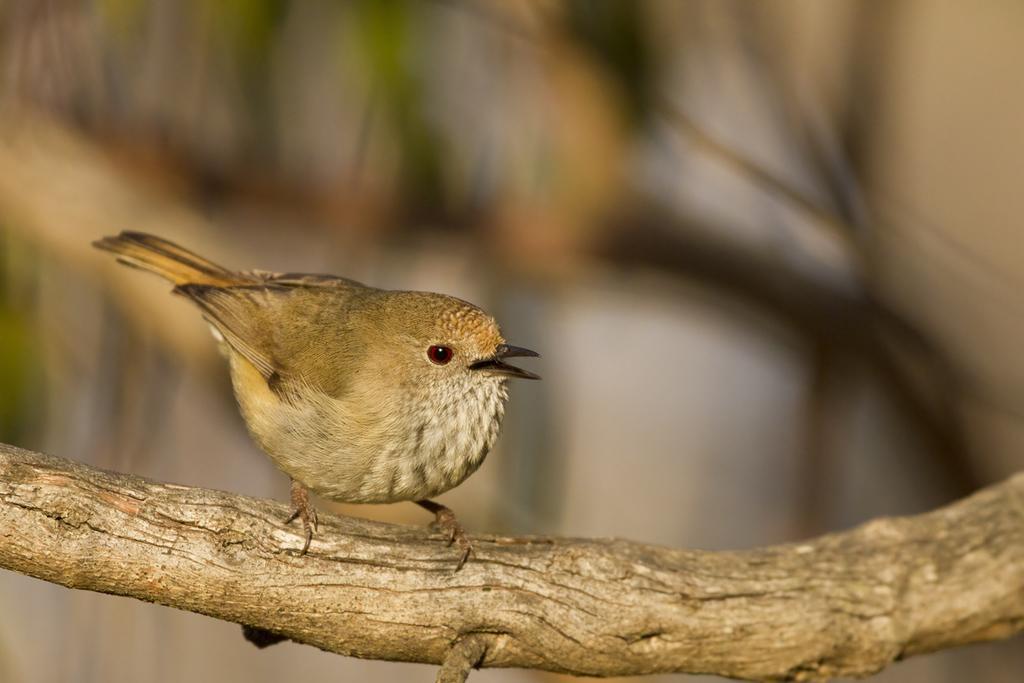Describe this image in one or two sentences. In this image we can see a bird on the wood and the background is blurred. 